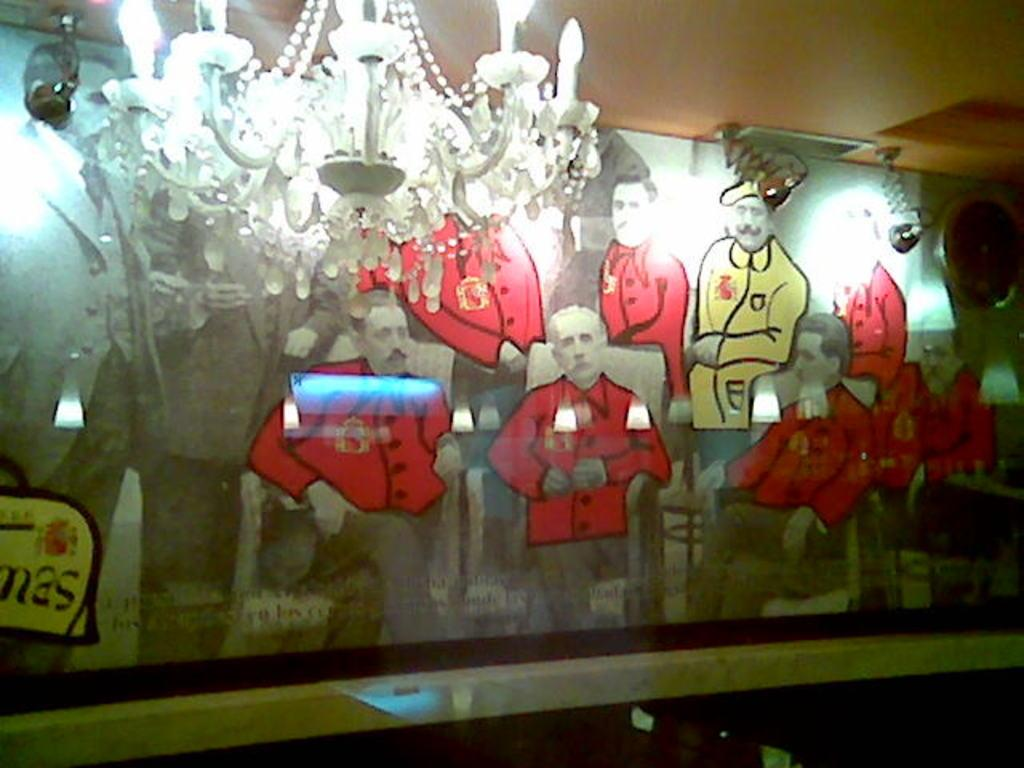What is the main subject in the center of the image? There is a poster in the center of the image. What type of lighting fixture is visible at the top side of the image? There is a chandelier at the top side of the image. Can you see a kettle being twisted by someone's lip in the image? No, there is no kettle or any action involving a lip in the image. 